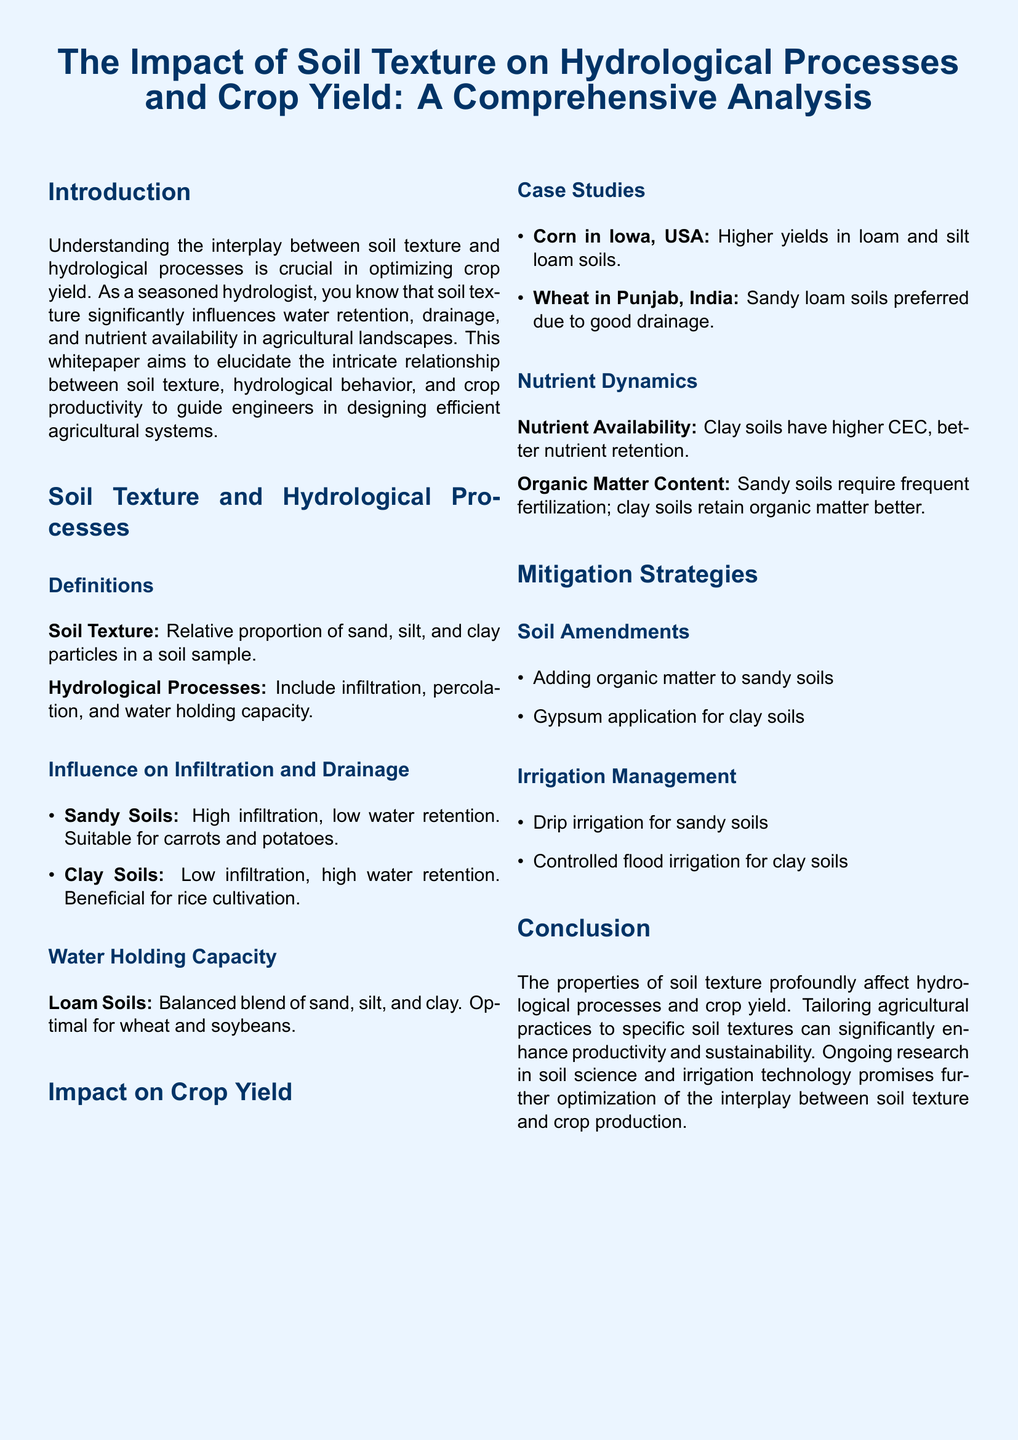what is the purpose of the whitepaper? The purpose is to elucidate the intricate relationship between soil texture, hydrological behavior, and crop productivity to guide engineers in designing efficient agricultural systems.
Answer: guide engineers what type of soil is beneficial for rice cultivation? The document states that clay soils are beneficial for rice cultivation due to their high water retention.
Answer: clay soils which soil type has high infiltration and low water retention? The document indicates that sandy soils have high infiltration and low water retention.
Answer: sandy soils what crop is preferred in sandy loam soils according to the case studies? The case studies mention that sandy loam soils are preferred for growing wheat in Punjab, India.
Answer: wheat what mitigation strategy is suggested for sandy soils? Adding organic matter to sandy soils is suggested as a mitigation strategy in the document.
Answer: organic matter how does clay soil affect nutrient retention? The document explains that clay soils have higher cation exchange capacity (CEC), which leads to better nutrient retention.
Answer: better nutrient retention which irrigation method is proposed for sandy soils? Drip irrigation is proposed for sandy soils as an effective management strategy.
Answer: drip irrigation which soil type is optimal for wheat and soybeans? The document describes loam soils as optimal for wheat and soybeans due to their balanced texture.
Answer: loam soils what was the finding for corn yields in Iowa? The document states that higher yields of corn are found in loam and silt loam soils in Iowa.
Answer: loam and silt loam soils 